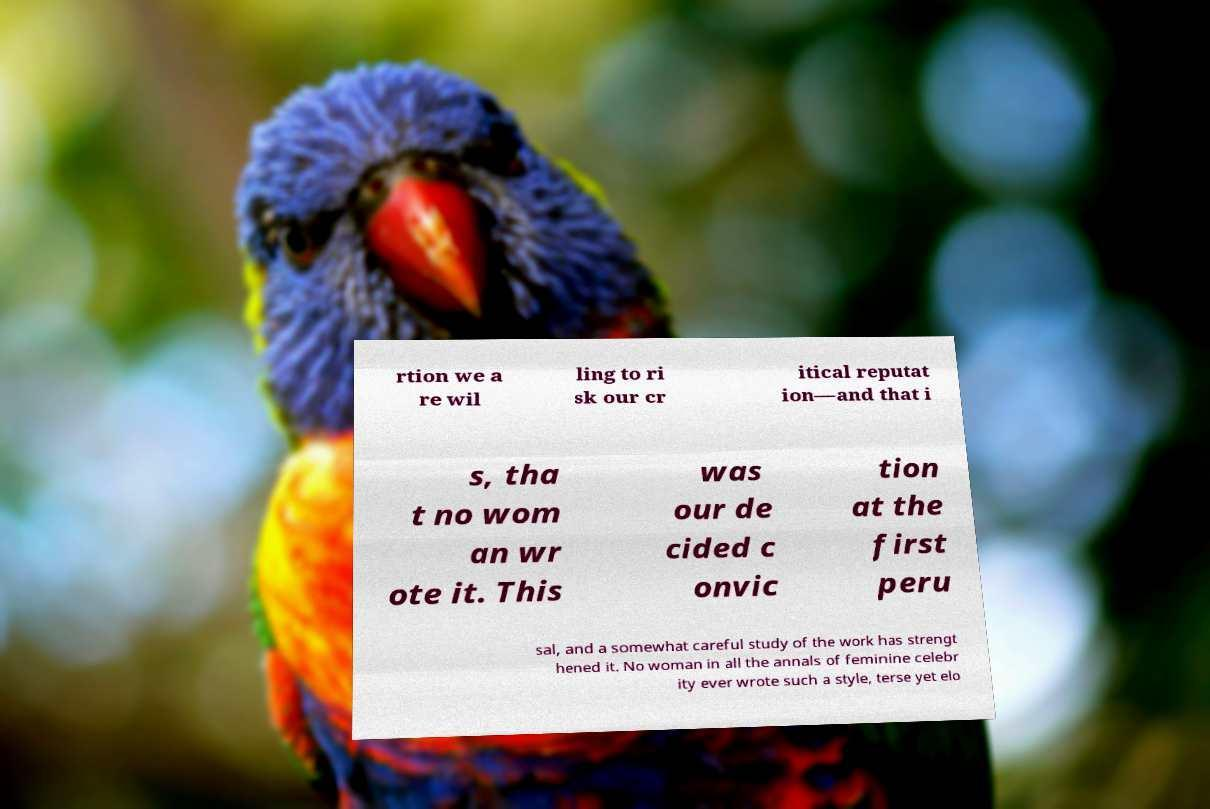Please identify and transcribe the text found in this image. rtion we a re wil ling to ri sk our cr itical reputat ion—and that i s, tha t no wom an wr ote it. This was our de cided c onvic tion at the first peru sal, and a somewhat careful study of the work has strengt hened it. No woman in all the annals of feminine celebr ity ever wrote such a style, terse yet elo 